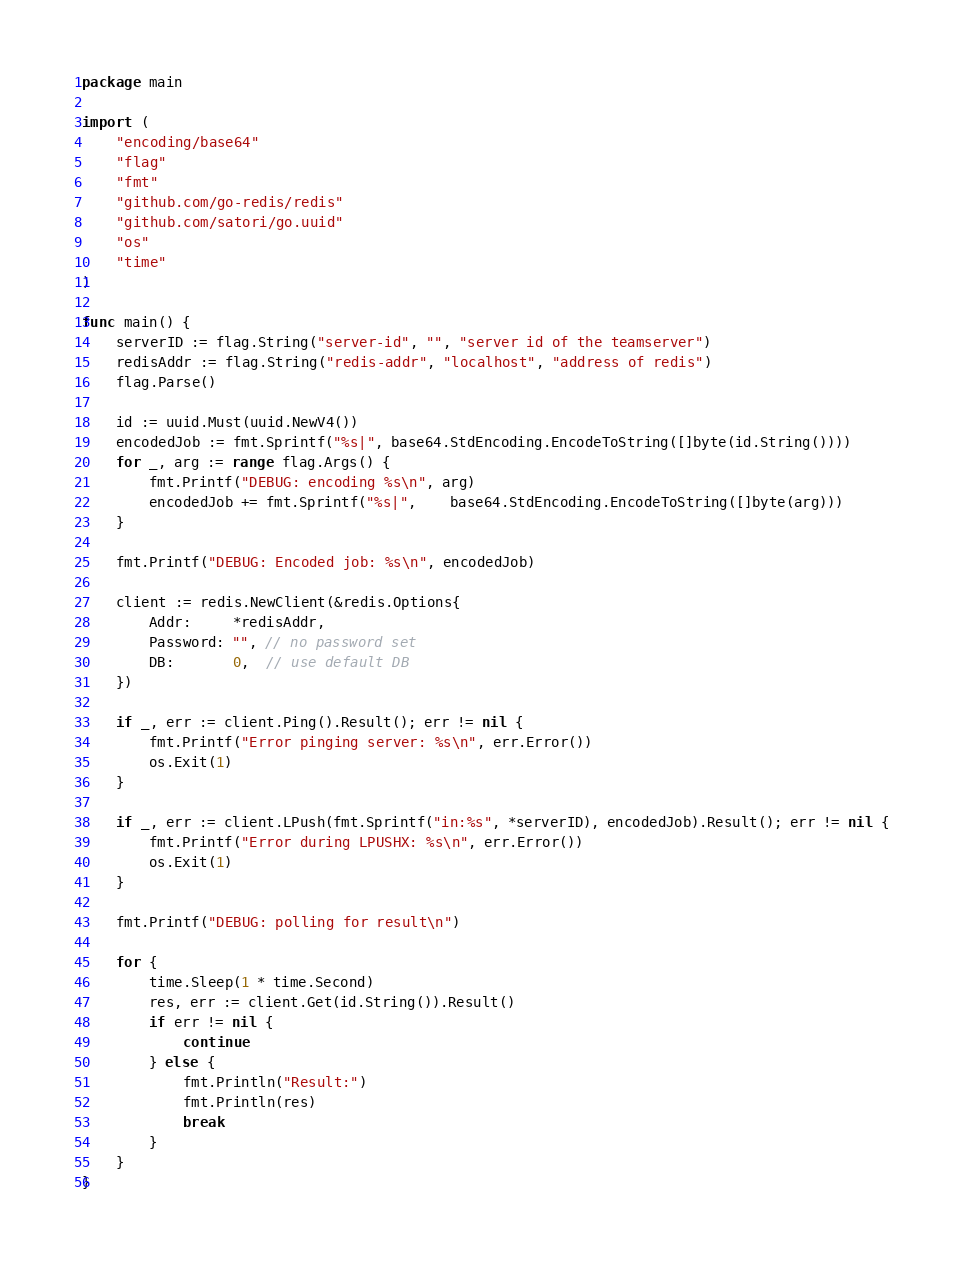Convert code to text. <code><loc_0><loc_0><loc_500><loc_500><_Go_>package main

import (
	"encoding/base64"
	"flag"
	"fmt"
	"github.com/go-redis/redis"
	"github.com/satori/go.uuid"
	"os"
	"time"
)

func main() {
	serverID := flag.String("server-id", "", "server id of the teamserver")
	redisAddr := flag.String("redis-addr", "localhost", "address of redis")
	flag.Parse()

	id := uuid.Must(uuid.NewV4())
	encodedJob := fmt.Sprintf("%s|", base64.StdEncoding.EncodeToString([]byte(id.String())))
	for _, arg := range flag.Args() {
		fmt.Printf("DEBUG: encoding %s\n", arg)
		encodedJob += fmt.Sprintf("%s|",	base64.StdEncoding.EncodeToString([]byte(arg)))
	}

	fmt.Printf("DEBUG: Encoded job: %s\n", encodedJob)

	client := redis.NewClient(&redis.Options{
		Addr:     *redisAddr,
		Password: "", // no password set
		DB:       0,  // use default DB
	})

	if _, err := client.Ping().Result(); err != nil {
		fmt.Printf("Error pinging server: %s\n", err.Error())
		os.Exit(1)
	}

	if _, err := client.LPush(fmt.Sprintf("in:%s", *serverID), encodedJob).Result(); err != nil {
		fmt.Printf("Error during LPUSHX: %s\n", err.Error())
		os.Exit(1)
	}

	fmt.Printf("DEBUG: polling for result\n")

	for {
		time.Sleep(1 * time.Second)
		res, err := client.Get(id.String()).Result()
		if err != nil {
			continue
		} else {
			fmt.Println("Result:")
			fmt.Println(res)
			break
		}
	}
}</code> 